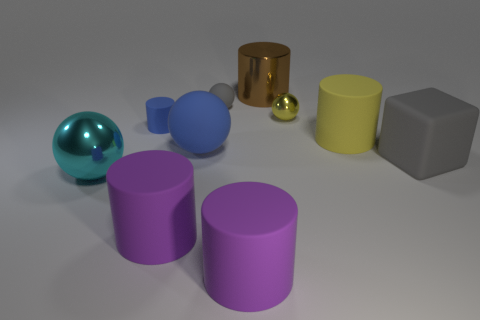Is there a yellow object of the same size as the yellow metal sphere?
Provide a succinct answer. No. Does the large thing that is behind the yellow cylinder have the same color as the large rubber block?
Your answer should be compact. No. What is the color of the sphere that is both behind the tiny cylinder and in front of the tiny gray ball?
Offer a terse response. Yellow. What is the shape of the metal object that is the same size as the metal cylinder?
Your answer should be compact. Sphere. Is there a green shiny object that has the same shape as the brown metal object?
Keep it short and to the point. No. There is a metal sphere that is in front of the cube; is its size the same as the big gray thing?
Provide a short and direct response. Yes. What is the size of the sphere that is both behind the large gray rubber thing and in front of the tiny rubber cylinder?
Offer a terse response. Large. How many other objects are the same material as the small gray thing?
Your answer should be compact. 6. What size is the metallic thing that is in front of the large block?
Give a very brief answer. Large. Is the tiny matte ball the same color as the tiny shiny object?
Make the answer very short. No. 